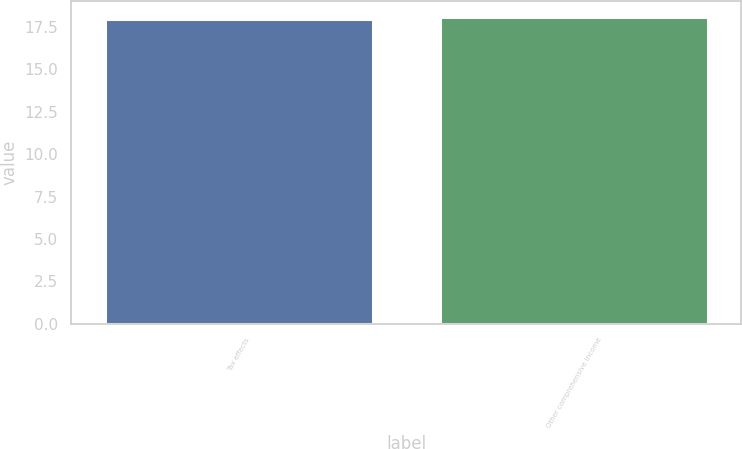Convert chart. <chart><loc_0><loc_0><loc_500><loc_500><bar_chart><fcel>Tax effects<fcel>Other comprehensive income<nl><fcel>18<fcel>18.1<nl></chart> 